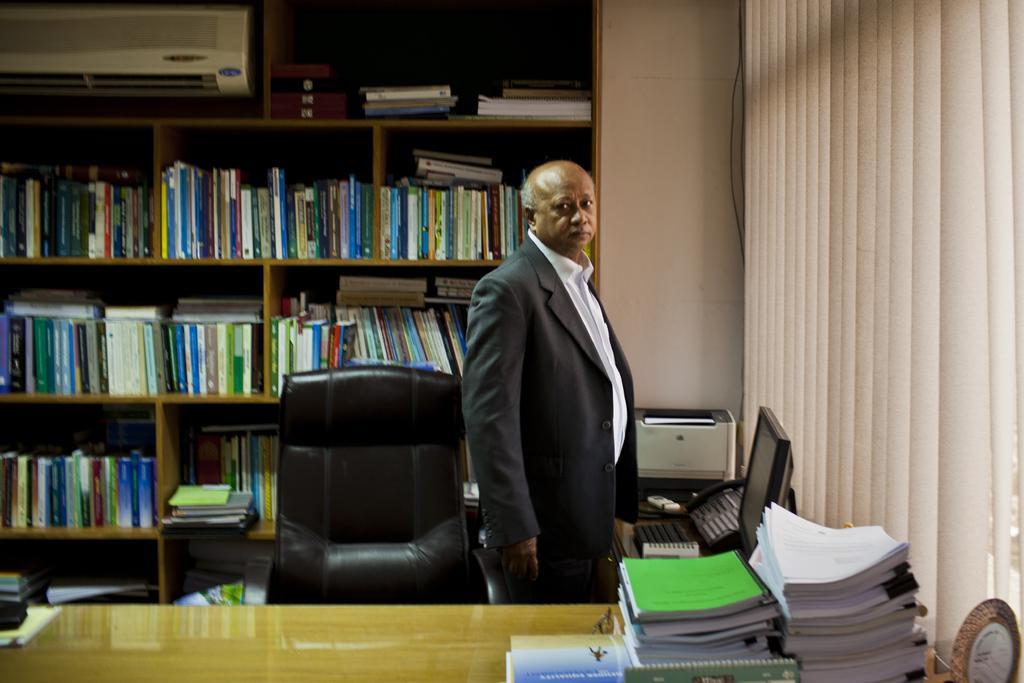Could you give a brief overview of what you see in this image? On the background we can see a wall. In the rack we can see books are arranged in a sequence manner. This is air conditioner. Here we can see chair and near to it there is a man standing. On the table we can see books, monitor, telephone , keyboard and a printer machine. 